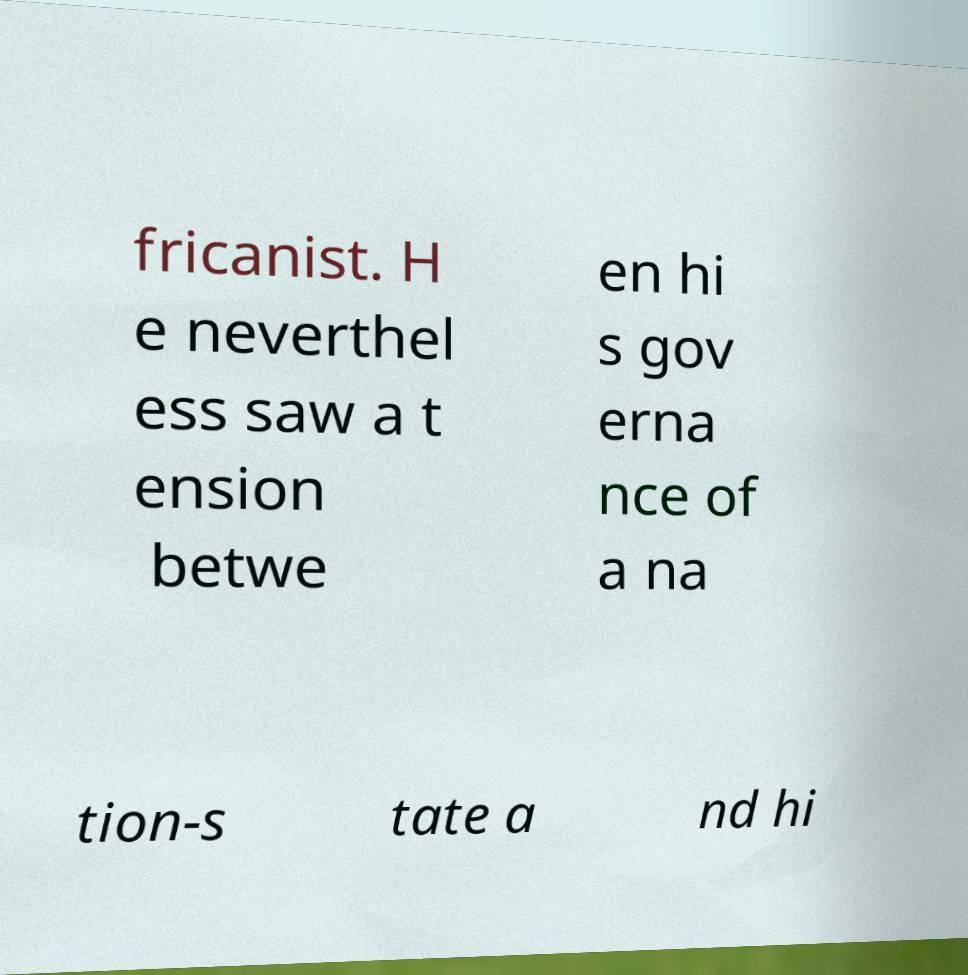Can you read and provide the text displayed in the image?This photo seems to have some interesting text. Can you extract and type it out for me? fricanist. H e neverthel ess saw a t ension betwe en hi s gov erna nce of a na tion-s tate a nd hi 